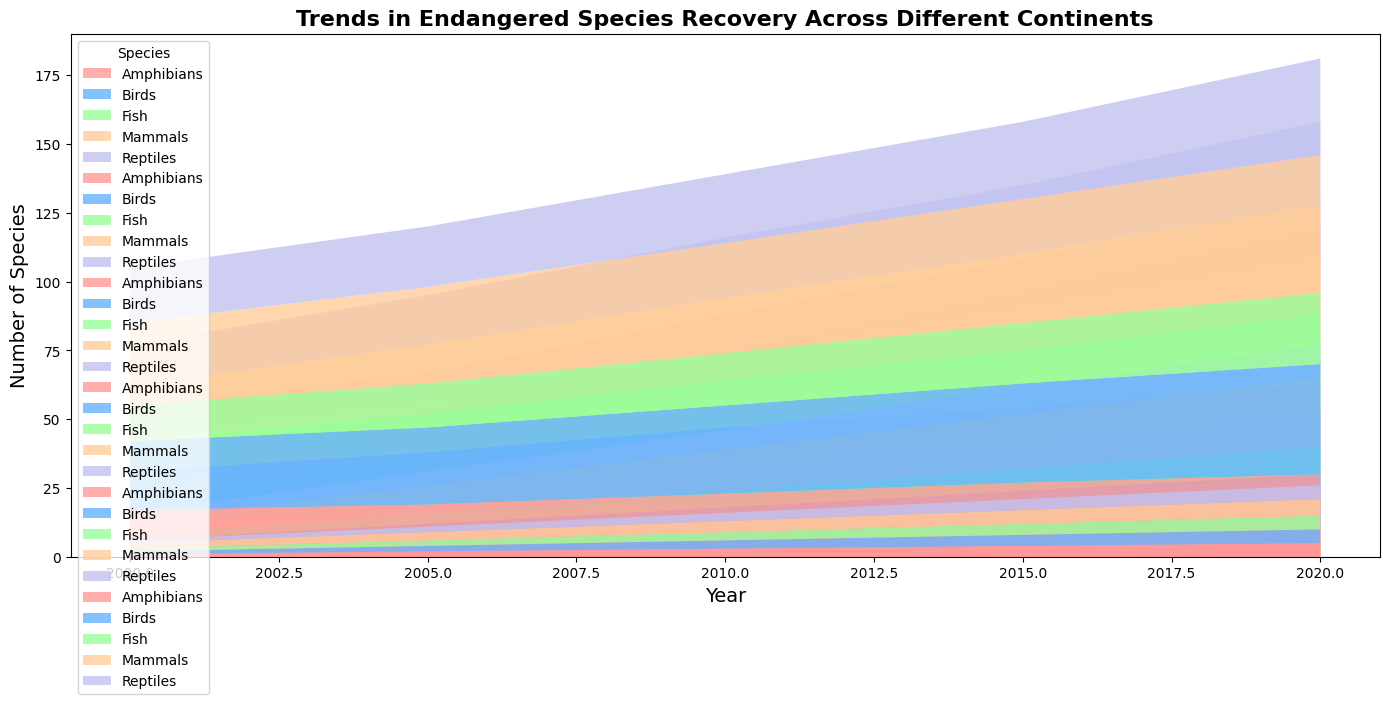Which continent showed the highest number of endangered mammals in 2020? By visually examining the height of the stacked areas in 2020, we can see that Asia has the highest number of mammals compared to other continents.
Answer: Asia How did the number of endangered birds in North America change from 2000 to 2020? By comparing the heights of the areas corresponding to birds in North America between 2000 and 2020, we see that the height increased from 8 in 2000 to 28 in 2020.
Answer: Increased Which species recovered the most in Europe from 2000 to 2020? By examining the entire height of stacked areas over time, it is evident that mammals had the greatest increase from 20 in 2000 to 40 in 2020.
Answer: Mammals What is the combined number of endangered reptiles in South America and Oceania in 2015? Add the heights (values) of reptiles in South America (18) and Oceania (4) for the year 2015. 18 + 4 = 22.
Answer: 22 Which continent exhibited the smallest increase in amphibian recovery from 2000 to 2020? By examining the stacked heights for amphibians across continents over the years and calculating their differences between 2000 and 2020, Oceania shows the smallest increase (from 1 to 5).
Answer: Oceania How does the trend of endangered mammals in Africa compare to that in North America between 2000 and 2020? By observing the stacked heights over time, mammals in Africa increase from 5 to 25, while in North America, they rise from 10 to 30. North America exhibits a steeper rise.
Answer: North America increased more What is the average number of endangered species for birds in Europe between 2000 and 2020? Sum the numbers for birds in Europe over each year (18+22+27+30+35) to get 132, then divide by the number of years (5). 132/5 = 26.4.
Answer: 26.4 Which species had the lowest total recovery across all continents in 2020? By visually comparing the heights of the areas for each species in 2020, fish have the lowest total across all continents based on their stacked area.
Answer: Fish Compare the recovery trends of reptiles in Asia versus amphibians in Asia from 2000 to 2020. Observe and compare the increases in the heights of the stacked areas. Reptiles increase from 20 to 35, while amphibians rise from 17 to 30, suggesting slightly higher growth for reptiles.
Answer: Reptiles increased more In which year did endangered fish in North America see the most significant increase? By visually examining the heights and changes over the years, 2015 shows a noticeable increase when comparing to previous years.
Answer: 2015 